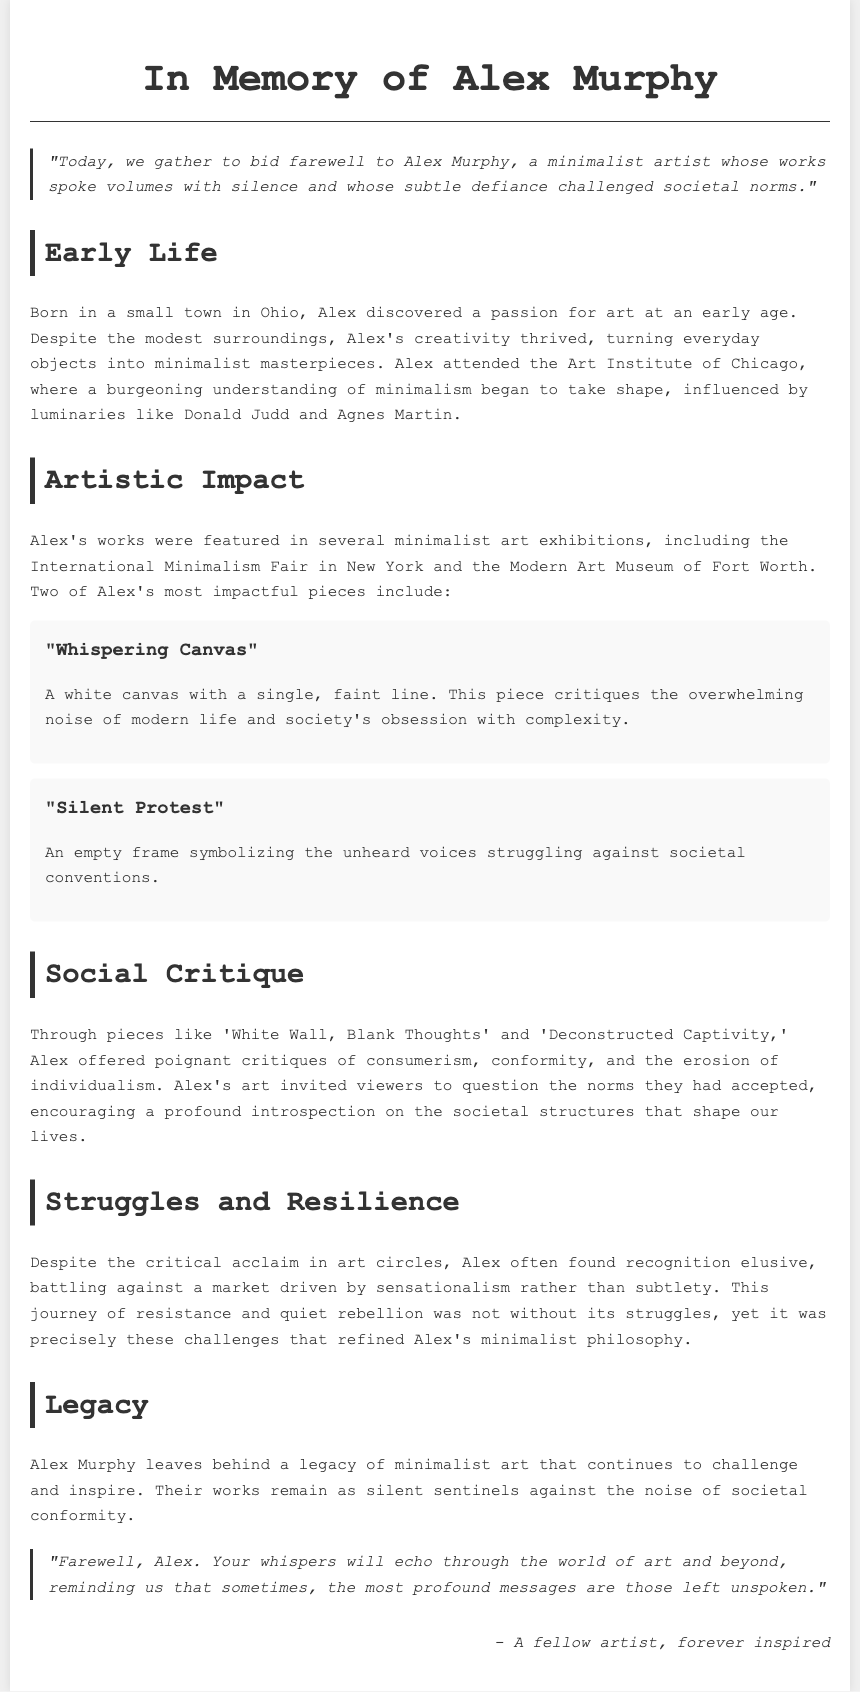What was Alex Murphy's passion at an early age? The document states that Alex discovered a passion for art at an early age.
Answer: Art What are the titles of two impactful pieces by Alex? The document mentions two impactful pieces: "Whispering Canvas" and "Silent Protest."
Answer: "Whispering Canvas" and "Silent Protest" Where did Alex attend art school? According to the document, Alex attended the Art Institute of Chicago.
Answer: Art Institute of Chicago What societal issue does "Whispering Canvas" critique? The piece critiques the overwhelming noise of modern life and society's obsession with complexity.
Answer: Overwhelming noise of modern life What theme is reflected in Alex's piece "Silent Protest"? This piece symbolizes the unheard voices struggling against societal conventions.
Answer: Unheard voices How did Alex's art encourage viewers? Alex's art invited viewers to question the norms they had accepted, encouraging profound introspection.
Answer: Question societal norms What type of recognition did Alex often struggle to achieve? Alex found recognition elusive, battling against a market driven by sensationalism.
Answer: Recognition What does the document end with? The document concludes with an expression of farewell and reminds of Alex's enduring message.
Answer: A farewell message 